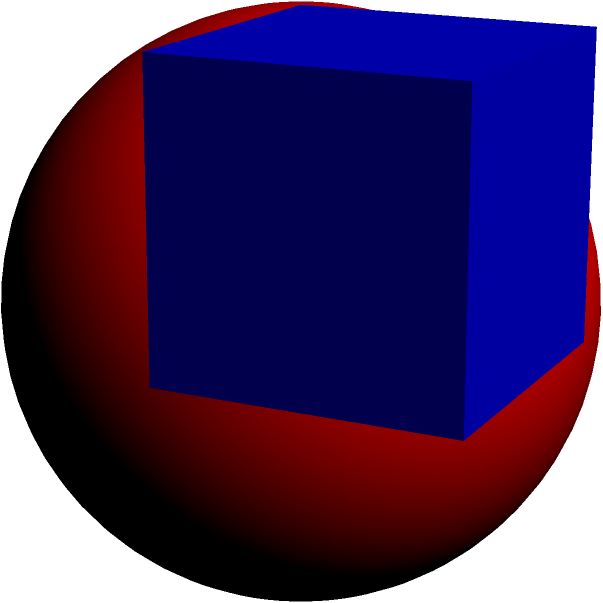As a scientist working on a project involving spatial geometry, you encounter a problem where a sphere is inscribed within a cube. The edge length of the cube is 10 cm. Calculate the volume of the inscribed sphere to the nearest cubic centimeter. Let's approach this step-by-step:

1) In an inscribed sphere, the diameter of the sphere is equal to the edge length of the cube. Therefore, the radius of the sphere is half the edge length of the cube.

2) Given:
   Edge length of cube = 10 cm
   Radius of sphere = 10/2 = 5 cm

3) The formula for the volume of a sphere is:
   $$V = \frac{4}{3}\pi r^3$$

4) Substituting our radius:
   $$V = \frac{4}{3}\pi (5)^3$$

5) Calculate:
   $$V = \frac{4}{3}\pi (125) = \frac{500\pi}{3} \approx 523.5987756 \text{ cm}^3$$

6) Rounding to the nearest cubic centimeter:
   $$V \approx 524 \text{ cm}^3$$
Answer: 524 cm³ 